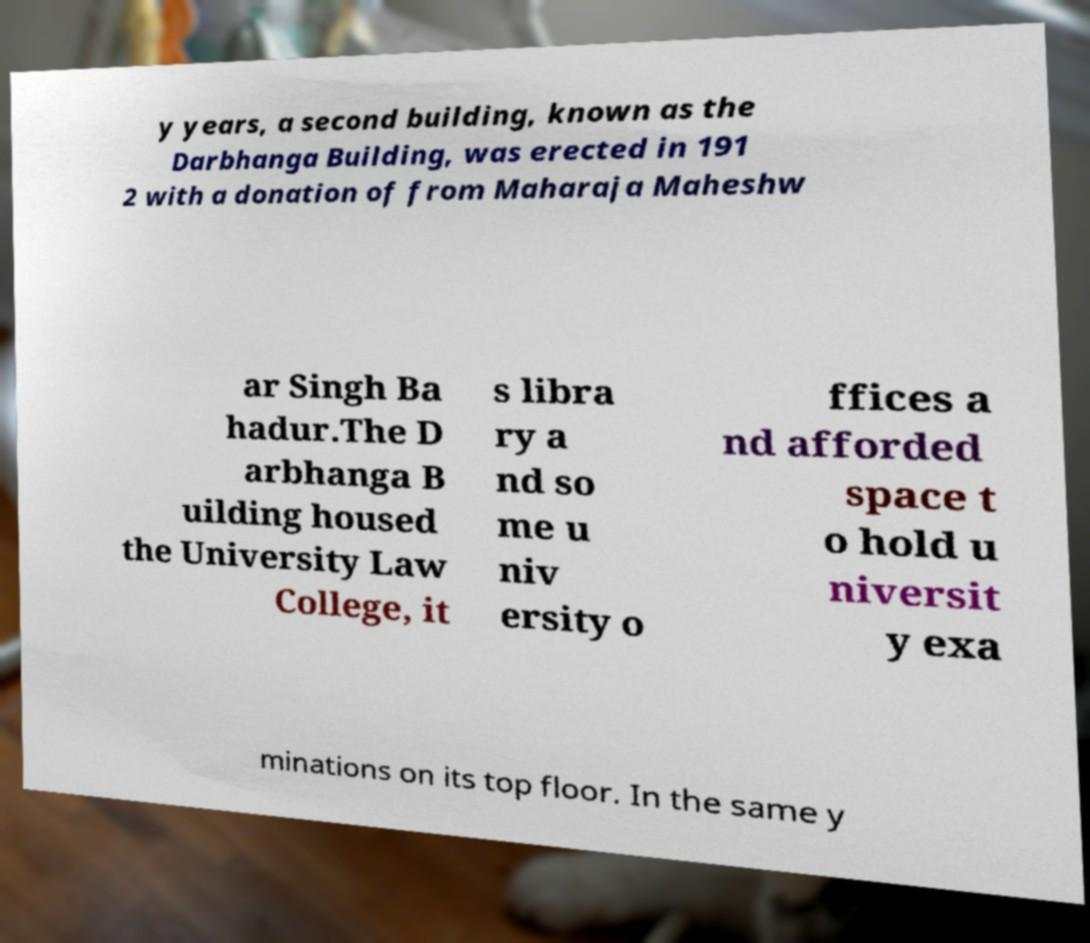Please read and relay the text visible in this image. What does it say? y years, a second building, known as the Darbhanga Building, was erected in 191 2 with a donation of from Maharaja Maheshw ar Singh Ba hadur.The D arbhanga B uilding housed the University Law College, it s libra ry a nd so me u niv ersity o ffices a nd afforded space t o hold u niversit y exa minations on its top floor. In the same y 